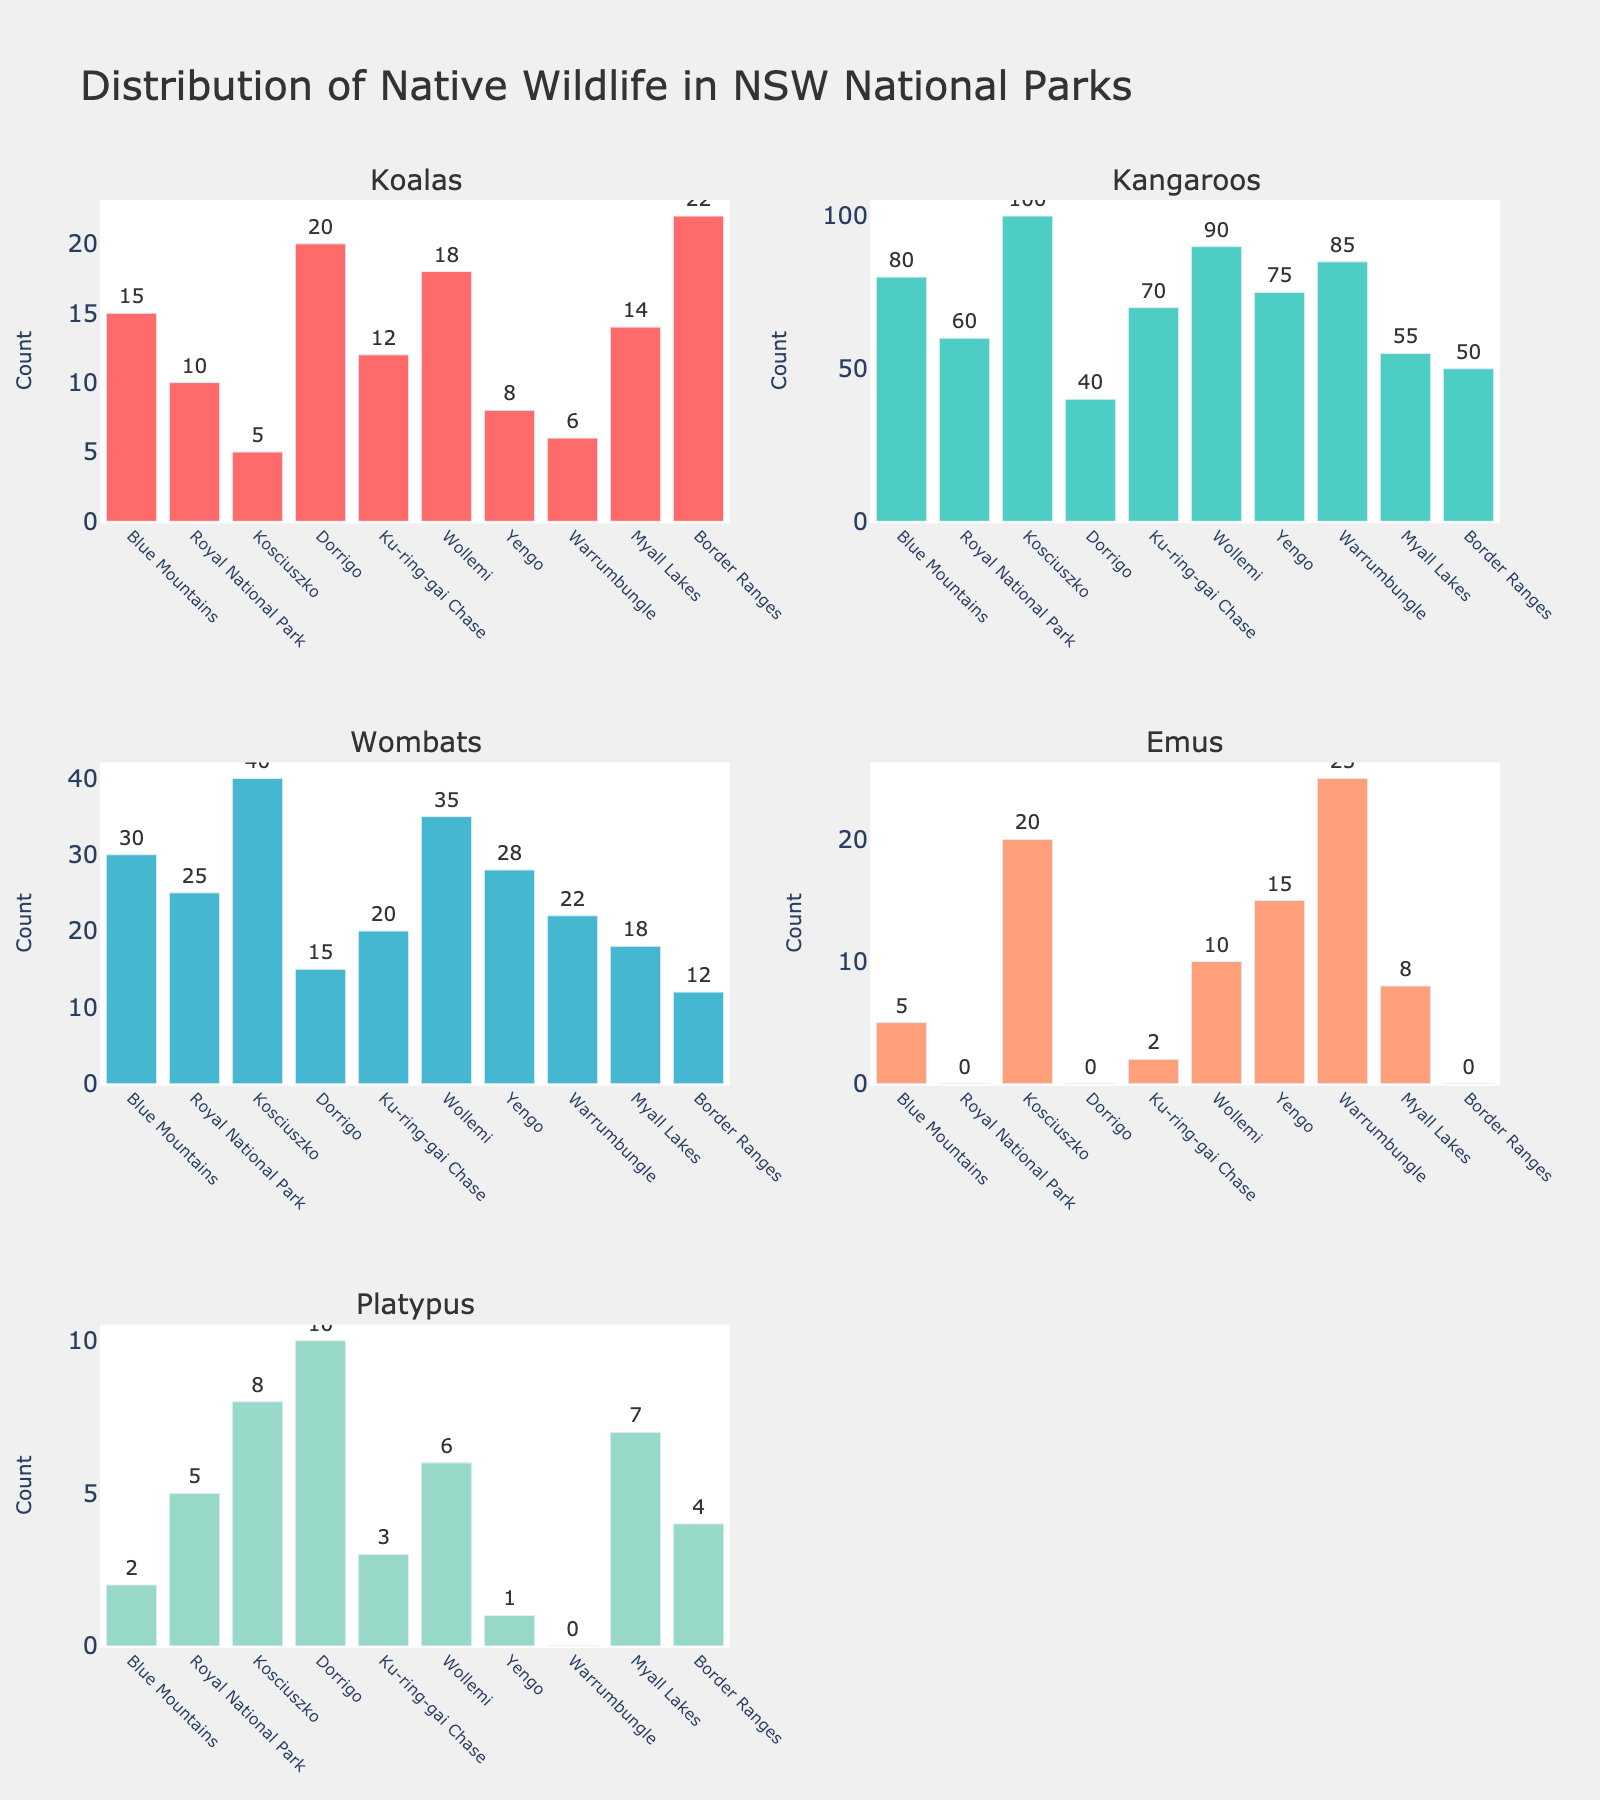what is the title of the figure? The title is located prominently at the top of the figure. It reads 'Distribution of Native Wildlife in NSW National Parks'.
Answer: Distribution of Native Wildlife in NSW National Parks What is the national park with the highest number of Kangaroos? By examining the subplot of Kangaroos, the highest bar corresponds to Kosciuszko with 100 Kangaroos.
Answer: Kosciuszko How many more Emus are in Warrumbungle compared to Blue Mountains? The subplot for Emus shows 25 in Warrumbungle and 5 in Blue Mountains. The difference is calculated as 25 - 5 = 20.
Answer: 20 Which animal has the largest total count across all parks? Sum the counts for each species from all parks and compare. Koalas: 130, Kangaroos: 715, Wombats: 275, Emus: 85, Platypus: 46. Kangaroos have the largest total count with 715.
Answer: Kangaroos Which park has the smallest number of Platypus? Check the subplot for Platypus and find the smallest bar, which is Yengo with 1 Platypus.
Answer: Yengo Between Blue Mountains and Dorrigo, which park has more Koalas, and by how many? Blue Mountains has 15 Koalas and Dorrigo has 20 Koalas. Dorrigo has more by 20 - 15 = 5.
Answer: Dorrigo, 5 What is the average number of Wombats across all the parks? Sum the Wombat counts and divide by the number of parks. (30+25+40+15+20+35+28+22+18+12)/10 = 24.5.
Answer: 24.5 Are there any parks with no Emus? Which ones? In the Emus subplot, Royal National Park, Dorrigo, and Border Ranges have a count of 0.
Answer: Royal National Park, Dorrigo, Border Ranges What is the total count of Platypus in Wollemi and Myall Lakes combined? From the Platypus subplot, Wollemi has 6 and Myall Lakes has 7. The total is 6 + 7 = 13.
Answer: 13 How many more animals in total (all species) are there in Ku-ring-gai Chase compared to Yengo? Sum the counts for each species in Ku-ring-gai Chase (12+70+20+2+3=107) and Yengo (8+75+28+15+1=127). Yengo has 127 - 107 = 20 more animals than Ku-ring-gai Chase.
Answer: 20 